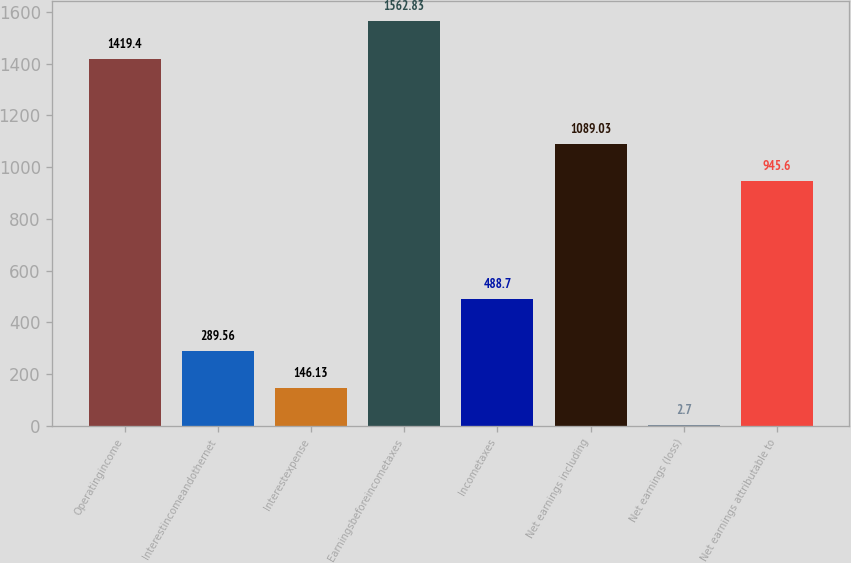Convert chart. <chart><loc_0><loc_0><loc_500><loc_500><bar_chart><fcel>Operatingincome<fcel>Interestincomeandothernet<fcel>Interestexpense<fcel>Earningsbeforeincometaxes<fcel>Incometaxes<fcel>Net earnings including<fcel>Net earnings (loss)<fcel>Net earnings attributable to<nl><fcel>1419.4<fcel>289.56<fcel>146.13<fcel>1562.83<fcel>488.7<fcel>1089.03<fcel>2.7<fcel>945.6<nl></chart> 